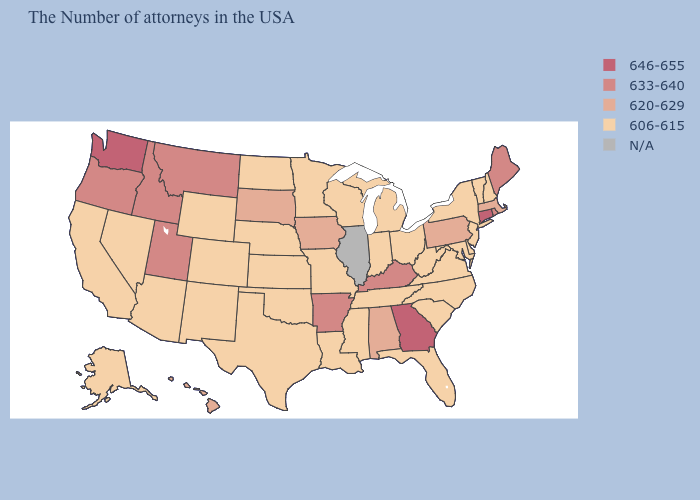Which states have the lowest value in the USA?
Answer briefly. New Hampshire, Vermont, New York, New Jersey, Delaware, Maryland, Virginia, North Carolina, South Carolina, West Virginia, Ohio, Florida, Michigan, Indiana, Tennessee, Wisconsin, Mississippi, Louisiana, Missouri, Minnesota, Kansas, Nebraska, Oklahoma, Texas, North Dakota, Wyoming, Colorado, New Mexico, Arizona, Nevada, California, Alaska. Name the states that have a value in the range N/A?
Keep it brief. Illinois. What is the highest value in the USA?
Give a very brief answer. 646-655. What is the value of Illinois?
Be succinct. N/A. What is the value of Virginia?
Be succinct. 606-615. What is the highest value in the USA?
Keep it brief. 646-655. How many symbols are there in the legend?
Be succinct. 5. Name the states that have a value in the range N/A?
Be succinct. Illinois. Name the states that have a value in the range N/A?
Be succinct. Illinois. Which states have the highest value in the USA?
Be succinct. Connecticut, Georgia, Washington. Name the states that have a value in the range 606-615?
Answer briefly. New Hampshire, Vermont, New York, New Jersey, Delaware, Maryland, Virginia, North Carolina, South Carolina, West Virginia, Ohio, Florida, Michigan, Indiana, Tennessee, Wisconsin, Mississippi, Louisiana, Missouri, Minnesota, Kansas, Nebraska, Oklahoma, Texas, North Dakota, Wyoming, Colorado, New Mexico, Arizona, Nevada, California, Alaska. Which states have the lowest value in the USA?
Write a very short answer. New Hampshire, Vermont, New York, New Jersey, Delaware, Maryland, Virginia, North Carolina, South Carolina, West Virginia, Ohio, Florida, Michigan, Indiana, Tennessee, Wisconsin, Mississippi, Louisiana, Missouri, Minnesota, Kansas, Nebraska, Oklahoma, Texas, North Dakota, Wyoming, Colorado, New Mexico, Arizona, Nevada, California, Alaska. Name the states that have a value in the range 606-615?
Quick response, please. New Hampshire, Vermont, New York, New Jersey, Delaware, Maryland, Virginia, North Carolina, South Carolina, West Virginia, Ohio, Florida, Michigan, Indiana, Tennessee, Wisconsin, Mississippi, Louisiana, Missouri, Minnesota, Kansas, Nebraska, Oklahoma, Texas, North Dakota, Wyoming, Colorado, New Mexico, Arizona, Nevada, California, Alaska. What is the value of Texas?
Be succinct. 606-615. 